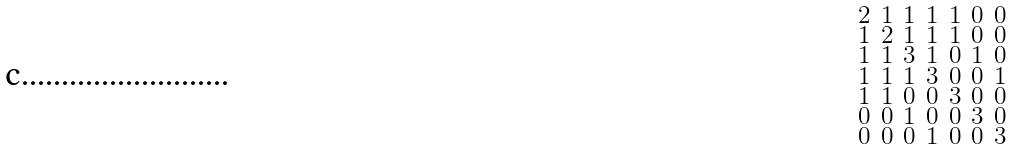Convert formula to latex. <formula><loc_0><loc_0><loc_500><loc_500>\begin{smallmatrix} 2 & 1 & 1 & 1 & 1 & 0 & 0 \\ 1 & 2 & 1 & 1 & 1 & 0 & 0 \\ 1 & 1 & 3 & 1 & 0 & 1 & 0 \\ 1 & 1 & 1 & 3 & 0 & 0 & 1 \\ 1 & 1 & 0 & 0 & 3 & 0 & 0 \\ 0 & 0 & 1 & 0 & 0 & 3 & 0 \\ 0 & 0 & 0 & 1 & 0 & 0 & 3 \end{smallmatrix}</formula> 